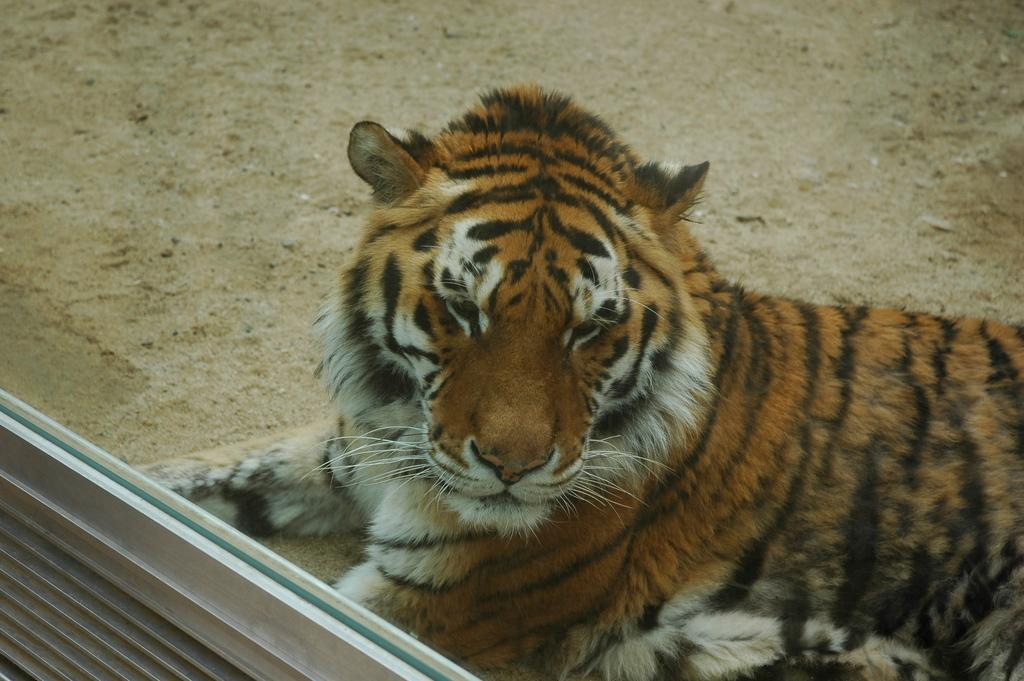What animal is in the image? There is a tiger in the image. What is the tiger's position in the image? The tiger is sitting on the land. Where is the wall with a glass window located in the image? The wall is located in the left bottom of the image. What color is the bell hanging from the wire in the image? There is no bell or wire present in the image. 